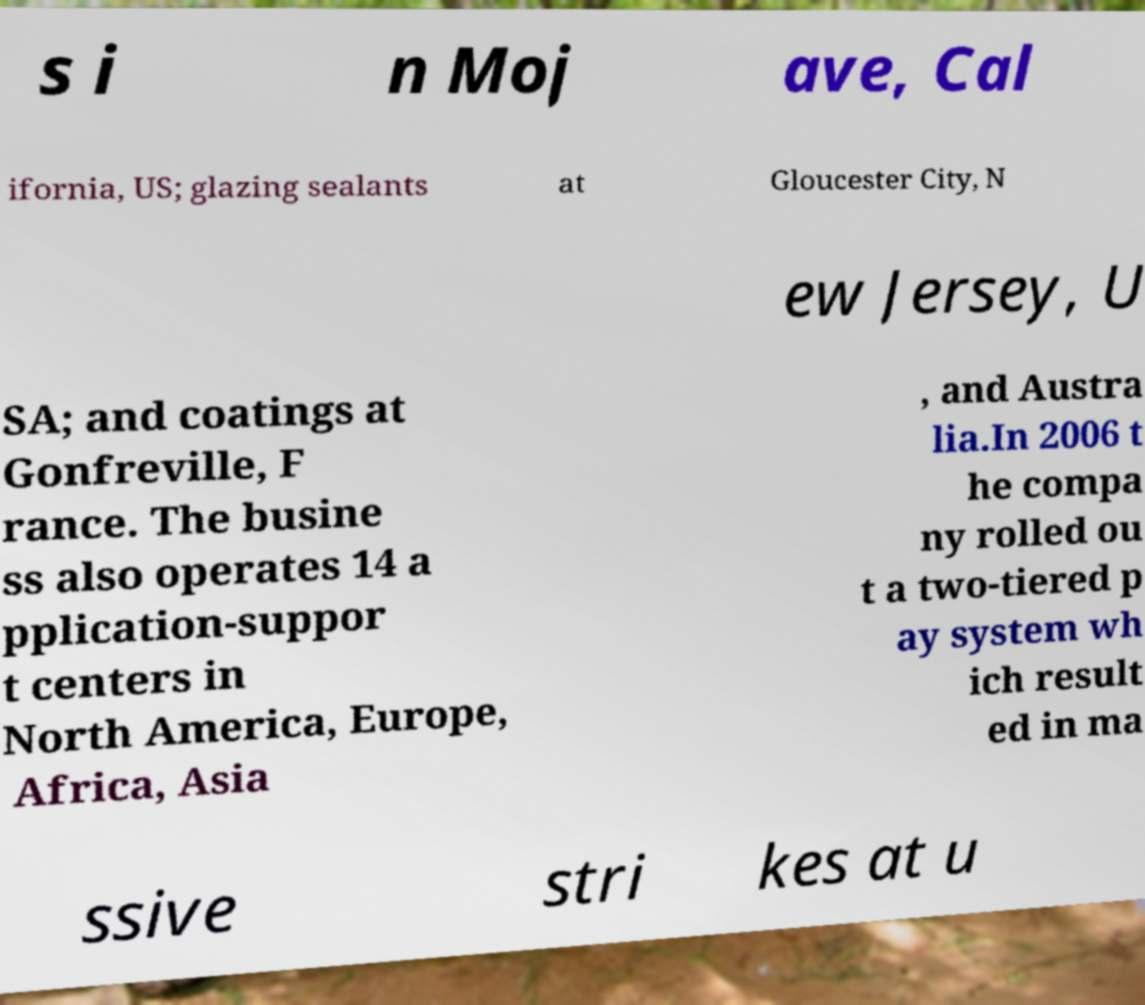I need the written content from this picture converted into text. Can you do that? s i n Moj ave, Cal ifornia, US; glazing sealants at Gloucester City, N ew Jersey, U SA; and coatings at Gonfreville, F rance. The busine ss also operates 14 a pplication-suppor t centers in North America, Europe, Africa, Asia , and Austra lia.In 2006 t he compa ny rolled ou t a two-tiered p ay system wh ich result ed in ma ssive stri kes at u 